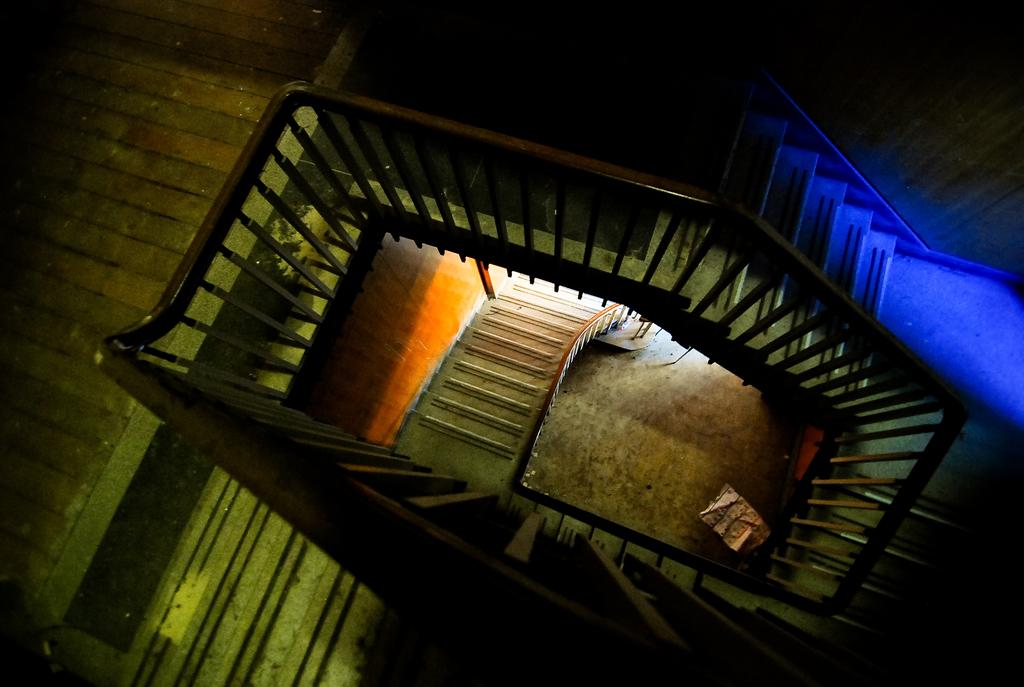What can be seen in the image that people might use to move between different levels? There are steps in the image that people might use to move between different levels. What is at the bottom of the steps? There is a floor at the bottom of the steps. What type of pump is visible on the steps in the image? There is no pump present in the image; it only features steps and a floor. 